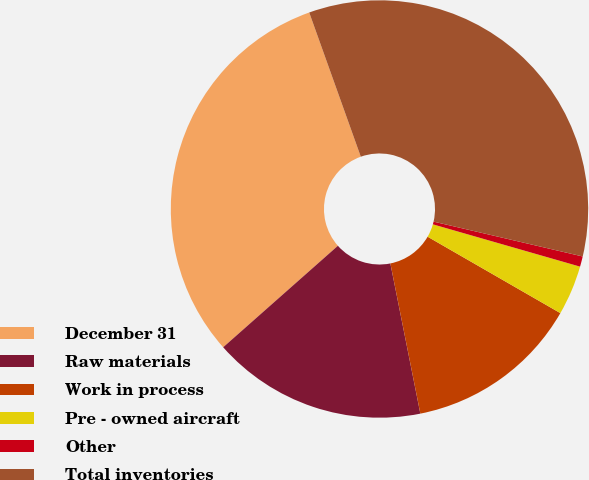Convert chart to OTSL. <chart><loc_0><loc_0><loc_500><loc_500><pie_chart><fcel>December 31<fcel>Raw materials<fcel>Work in process<fcel>Pre - owned aircraft<fcel>Other<fcel>Total inventories<nl><fcel>31.06%<fcel>16.61%<fcel>13.55%<fcel>3.86%<fcel>0.8%<fcel>34.12%<nl></chart> 